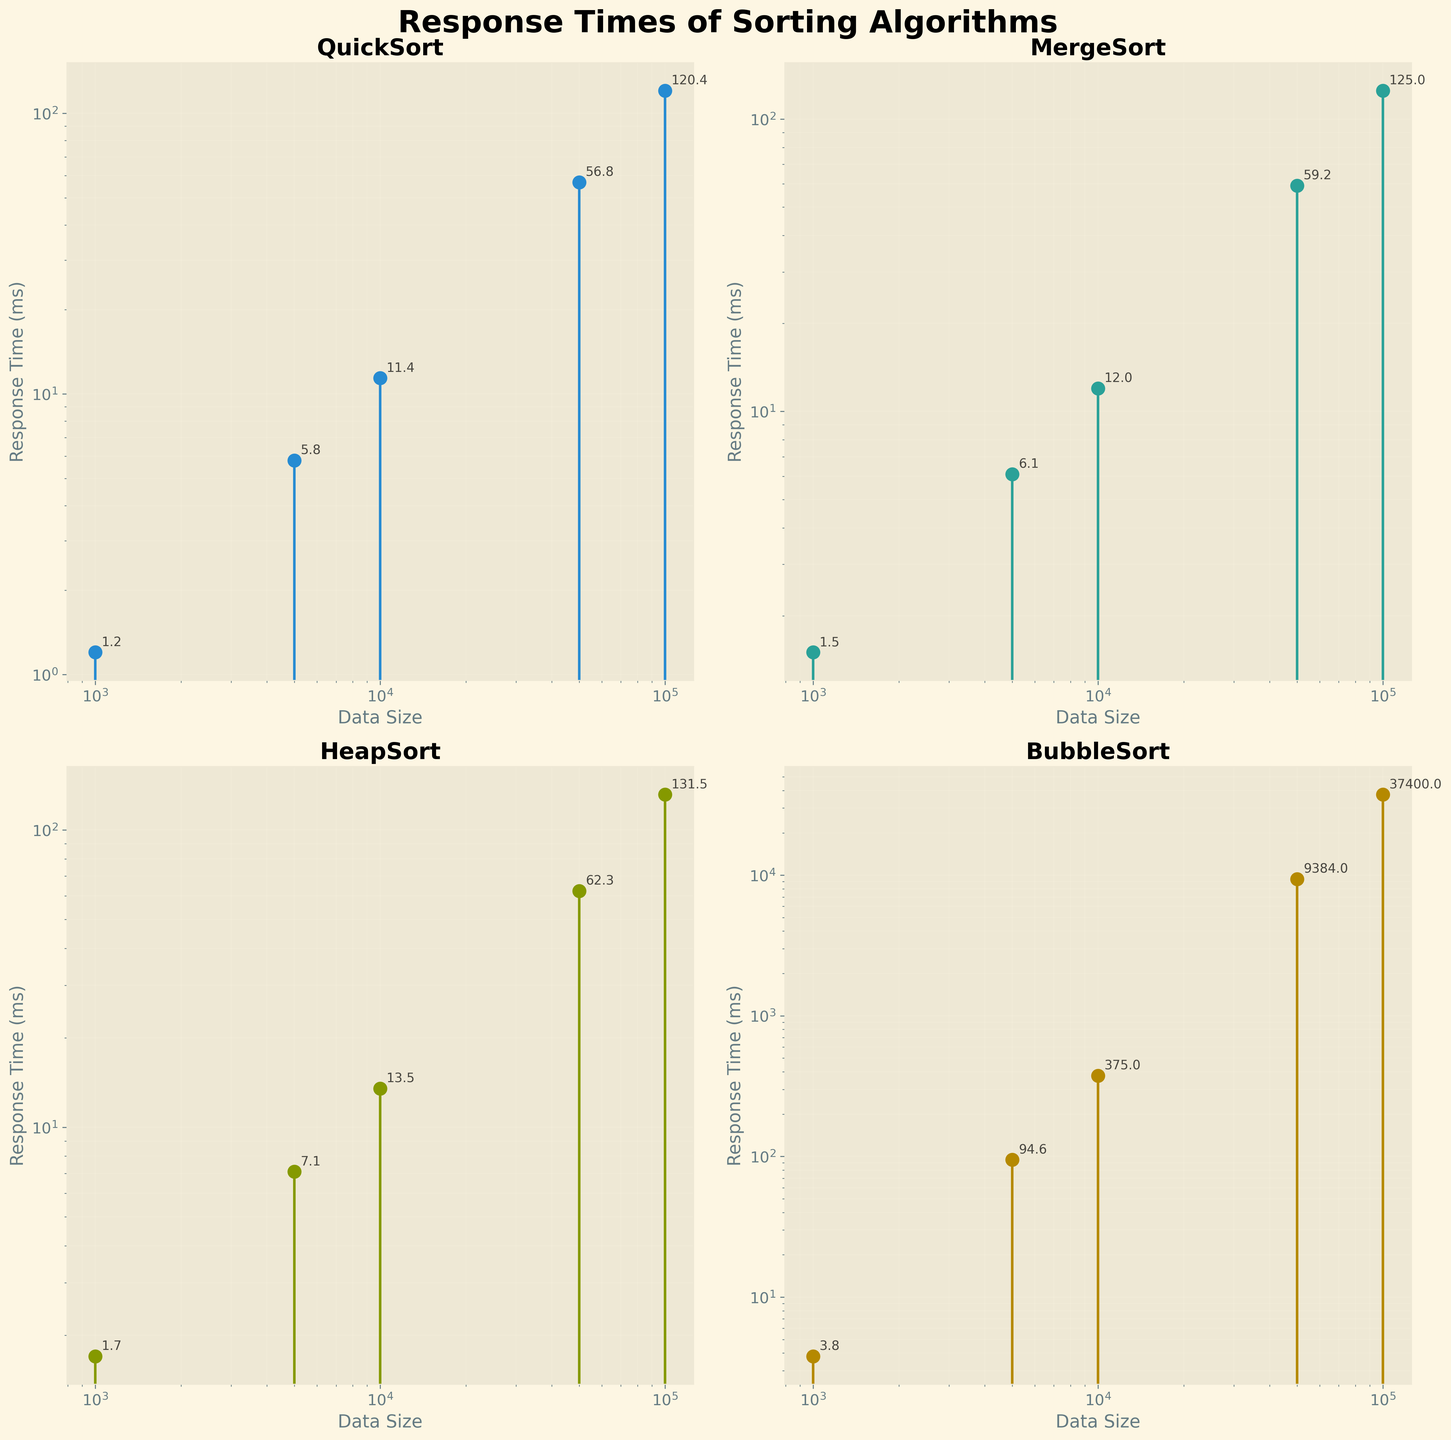What's the title of the entire figure? The title is located at the top center of the figure, it reads "Response Times of Sorting Algorithms".
Answer: Response Times of Sorting Algorithms How many subplots are there in the figure? There are four subplots arranged in a 2x2 grid, one for each sorting algorithm as indicated by the two rows and two columns of the subplots.
Answer: Four Which algorithm has the largest response time for the data size of 50,000? By looking at the subplot titles and the y-values marked on the stems, BubbleSort has the largest response time of 9384 ms for a data size of 50,000.
Answer: BubbleSort What is the smallest response time shown for QuickSort, and for which data size? In the QuickSort subplot, the smallest response time is 1.2 ms for a data size of 1,000.
Answer: 1.2 ms for 1,000 Arrange the algorithms in order from fastest to slowest average response time for the largest data size (100,000). From the subplots, the response times at 100,000 data size are as follows: QuickSort: 120.4 ms, MergeSort: 125.0 ms, HeapSort: 131.5 ms, and BubbleSort: 37,400.0 ms. Sorting these, we get QuickSort, MergeSort, HeapSort, and BubbleSort.
Answer: QuickSort, MergeSort, HeapSort, BubbleSort Which algorithm shows the steepest increase in response time with increasing data size? BubbleSort demonstrates a highly dramatic increase in response time with increasing data size, growing from 3.8 ms for 1,000 to 37,400 ms for 100,000, displaying an exponential growth pattern.
Answer: BubbleSort What is the difference in response times between MergeSort and HeapSort for the data size of 10,000? From the subplots, MergeSort's response time for 10,000 is 12.0 ms and HeapSort's is 13.5 ms. The difference is 13.5 - 12.0 = 1.5 ms.
Answer: 1.5 ms For the data size of 5,000, how does QuickSort's response time compare to MergeSort's? For 5,000 data size, QuickSort has a response time of 5.8 ms while MergeSort has a response time of 6.1 ms. QuickSort is faster than MergeSort by 0.3 ms.
Answer: QuickSort is 0.3 ms faster What is the range of response times for the QuickSort algorithm? The range is determined by subtracting the smallest response time (1.2 ms for 1,000) from the largest response time (120.4 ms for 100,000). So, the range is 120.4 - 1.2 = 119.2 ms.
Answer: 119.2 ms For which data size is the response time closest to 10 ms for any algorithm? We spot-check each subplot, and for QuickSort at 10,000 data size, the response time is 11.4 ms; MergeSort at 10,000 shows 12.0 ms which is higher; none of HeapSort or BubbleSort times around this value for given data sizes. QuickSort's response time of 11.4 ms is closest to 10 ms.
Answer: Data size of 10,000 for QuickSort 